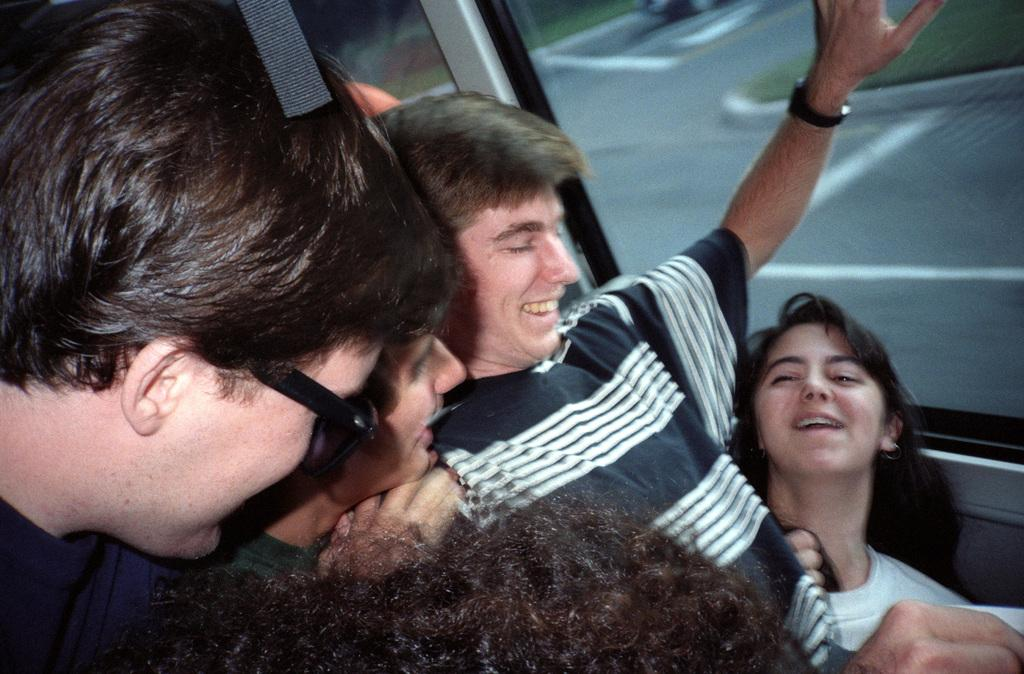Who or what can be seen in the bottom of the image? There are persons in the bottom of the image. What type of architectural feature is present on the right side of the image? There is a glass window on the right side of the image. How many bridges can be seen in the image? There are no bridges present in the image. What type of team is visible in the image? There is no team visible in the image; it features persons and a glass window. 